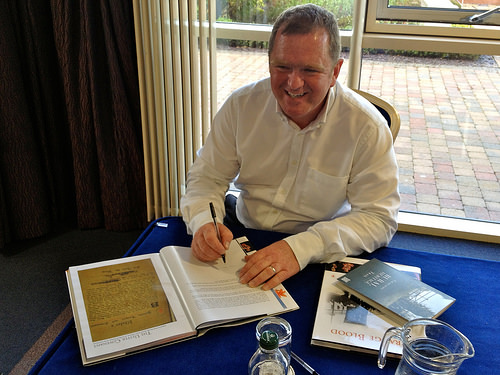<image>
Is the book on the table? Yes. Looking at the image, I can see the book is positioned on top of the table, with the table providing support. 